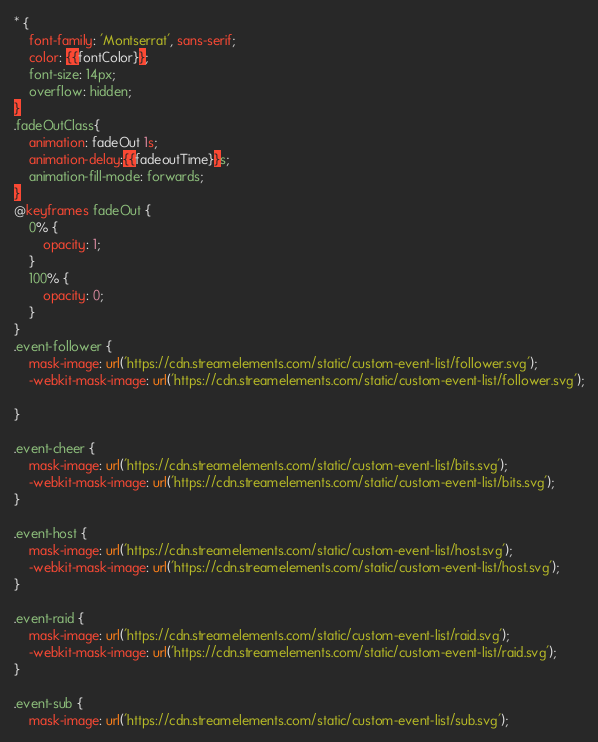Convert code to text. <code><loc_0><loc_0><loc_500><loc_500><_CSS_>* {
    font-family: 'Montserrat', sans-serif;
    color: {{fontColor}};
    font-size: 14px;
    overflow: hidden;
}
.fadeOutClass{
    animation: fadeOut 1s;
    animation-delay:{{fadeoutTime}}s;
    animation-fill-mode: forwards;
}
@keyframes fadeOut {
    0% {
        opacity: 1;
    }
    100% {
        opacity: 0;
    }
}
.event-follower {
    mask-image: url('https://cdn.streamelements.com/static/custom-event-list/follower.svg');
    -webkit-mask-image: url('https://cdn.streamelements.com/static/custom-event-list/follower.svg');

}

.event-cheer {
    mask-image: url('https://cdn.streamelements.com/static/custom-event-list/bits.svg');
    -webkit-mask-image: url('https://cdn.streamelements.com/static/custom-event-list/bits.svg');
}

.event-host {
    mask-image: url('https://cdn.streamelements.com/static/custom-event-list/host.svg');
    -webkit-mask-image: url('https://cdn.streamelements.com/static/custom-event-list/host.svg');
}

.event-raid {
    mask-image: url('https://cdn.streamelements.com/static/custom-event-list/raid.svg');
    -webkit-mask-image: url('https://cdn.streamelements.com/static/custom-event-list/raid.svg');
}

.event-sub {
    mask-image: url('https://cdn.streamelements.com/static/custom-event-list/sub.svg');</code> 